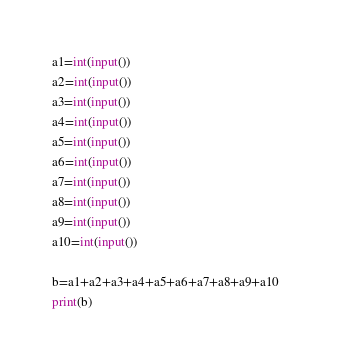Convert code to text. <code><loc_0><loc_0><loc_500><loc_500><_Python_>a1=int(input())
a2=int(input())
a3=int(input())
a4=int(input())
a5=int(input())
a6=int(input())
a7=int(input())
a8=int(input())
a9=int(input())
a10=int(input())

b=a1+a2+a3+a4+a5+a6+a7+a8+a9+a10    
print(b)

</code> 